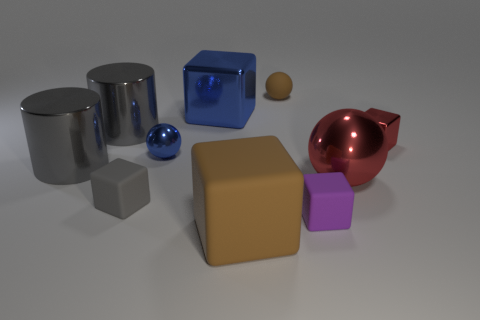What size is the purple cube that is the same material as the small gray object?
Give a very brief answer. Small. What number of other balls have the same size as the brown sphere?
Make the answer very short. 1. What is the size of the metallic cube that is the same color as the large metallic sphere?
Keep it short and to the point. Small. What is the color of the big metallic cylinder that is in front of the tiny shiny thing that is to the left of the large blue cube?
Offer a terse response. Gray. Is there a rubber sphere that has the same color as the tiny metallic block?
Your answer should be very brief. No. There is a shiny cube that is the same size as the blue sphere; what is its color?
Offer a terse response. Red. Is the big thing in front of the small gray rubber object made of the same material as the big red thing?
Give a very brief answer. No. Are there any large blue shiny things that are on the right side of the large gray shiny thing in front of the red thing that is right of the red ball?
Offer a very short reply. Yes. There is a large thing that is right of the big rubber block; is it the same shape as the small brown rubber object?
Your answer should be very brief. Yes. What shape is the small rubber thing behind the metal ball on the right side of the small shiny sphere?
Give a very brief answer. Sphere. 